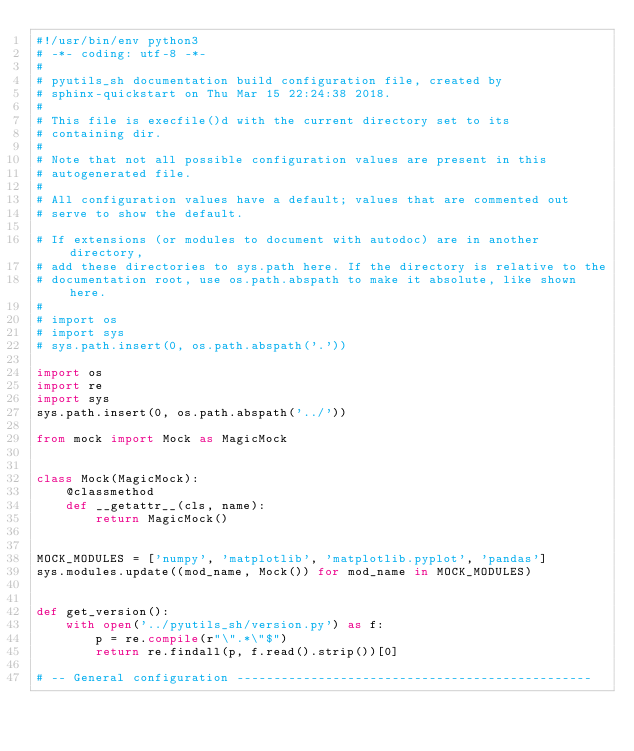Convert code to text. <code><loc_0><loc_0><loc_500><loc_500><_Python_>#!/usr/bin/env python3
# -*- coding: utf-8 -*-
#
# pyutils_sh documentation build configuration file, created by
# sphinx-quickstart on Thu Mar 15 22:24:38 2018.
#
# This file is execfile()d with the current directory set to its
# containing dir.
#
# Note that not all possible configuration values are present in this
# autogenerated file.
#
# All configuration values have a default; values that are commented out
# serve to show the default.

# If extensions (or modules to document with autodoc) are in another directory,
# add these directories to sys.path here. If the directory is relative to the
# documentation root, use os.path.abspath to make it absolute, like shown here.
#
# import os
# import sys
# sys.path.insert(0, os.path.abspath('.'))

import os
import re
import sys
sys.path.insert(0, os.path.abspath('../'))

from mock import Mock as MagicMock


class Mock(MagicMock):
    @classmethod
    def __getattr__(cls, name):
        return MagicMock()


MOCK_MODULES = ['numpy', 'matplotlib', 'matplotlib.pyplot', 'pandas']
sys.modules.update((mod_name, Mock()) for mod_name in MOCK_MODULES)


def get_version():
    with open('../pyutils_sh/version.py') as f:
        p = re.compile(r"\".*\"$")
        return re.findall(p, f.read().strip())[0]

# -- General configuration ------------------------------------------------
</code> 